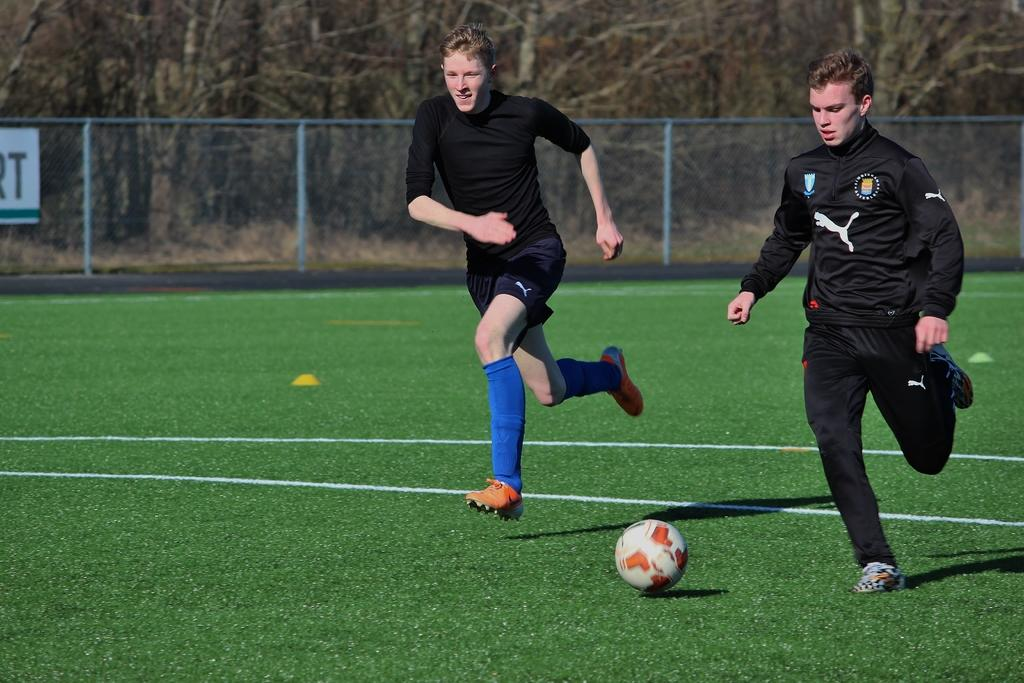What is the ground is covered with in the image? There is green grass on the ground in the image. What are the two boys doing in the image? The two boys are playing football in the image. What can be seen in the background of the image? There is a fencing and trees in the background of the image. What type of hand is holding the football in the image? There is no hand holding the football in the image; the boys are using their feet to play football. How does the goose feel about the football game in the image? There is no goose present in the image, so it cannot have any feelings about the football game. 